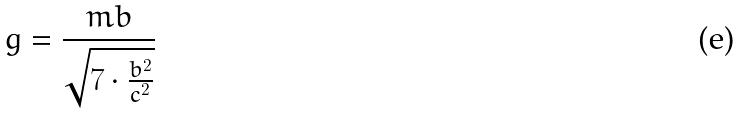<formula> <loc_0><loc_0><loc_500><loc_500>g = \frac { m b } { \sqrt { 7 \cdot \frac { b ^ { 2 } } { c ^ { 2 } } } }</formula> 